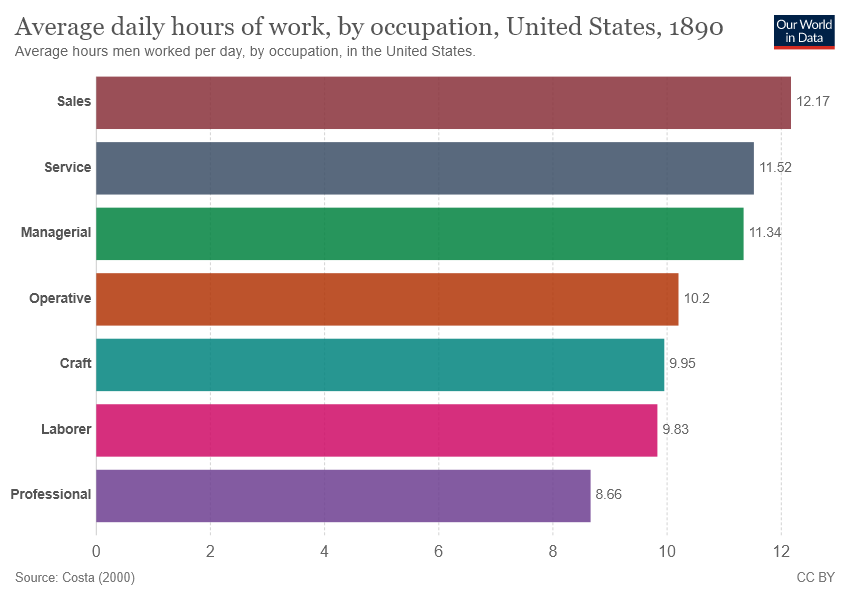Point out several critical features in this image. The sum of a laborer and a professional is 18.49. There are 7 color bars in the graph. 